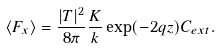<formula> <loc_0><loc_0><loc_500><loc_500>\langle F _ { x } \rangle = \frac { | T | ^ { 2 } } { 8 \pi } \frac { K } { k } \exp ( - 2 q z ) C _ { e x t } .</formula> 